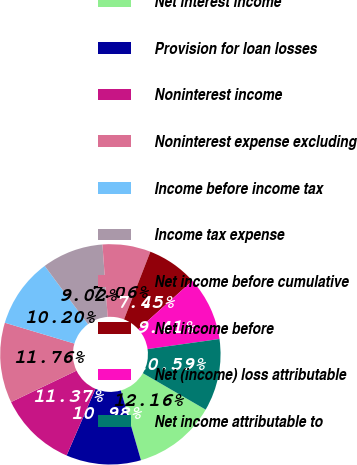Convert chart to OTSL. <chart><loc_0><loc_0><loc_500><loc_500><pie_chart><fcel>Net interest income<fcel>Provision for loan losses<fcel>Noninterest income<fcel>Noninterest expense excluding<fcel>Income before income tax<fcel>Income tax expense<fcel>Net income before cumulative<fcel>Net income before<fcel>Net (income) loss attributable<fcel>Net income attributable to<nl><fcel>12.16%<fcel>10.98%<fcel>11.37%<fcel>11.76%<fcel>10.2%<fcel>9.02%<fcel>7.06%<fcel>7.45%<fcel>9.41%<fcel>10.59%<nl></chart> 